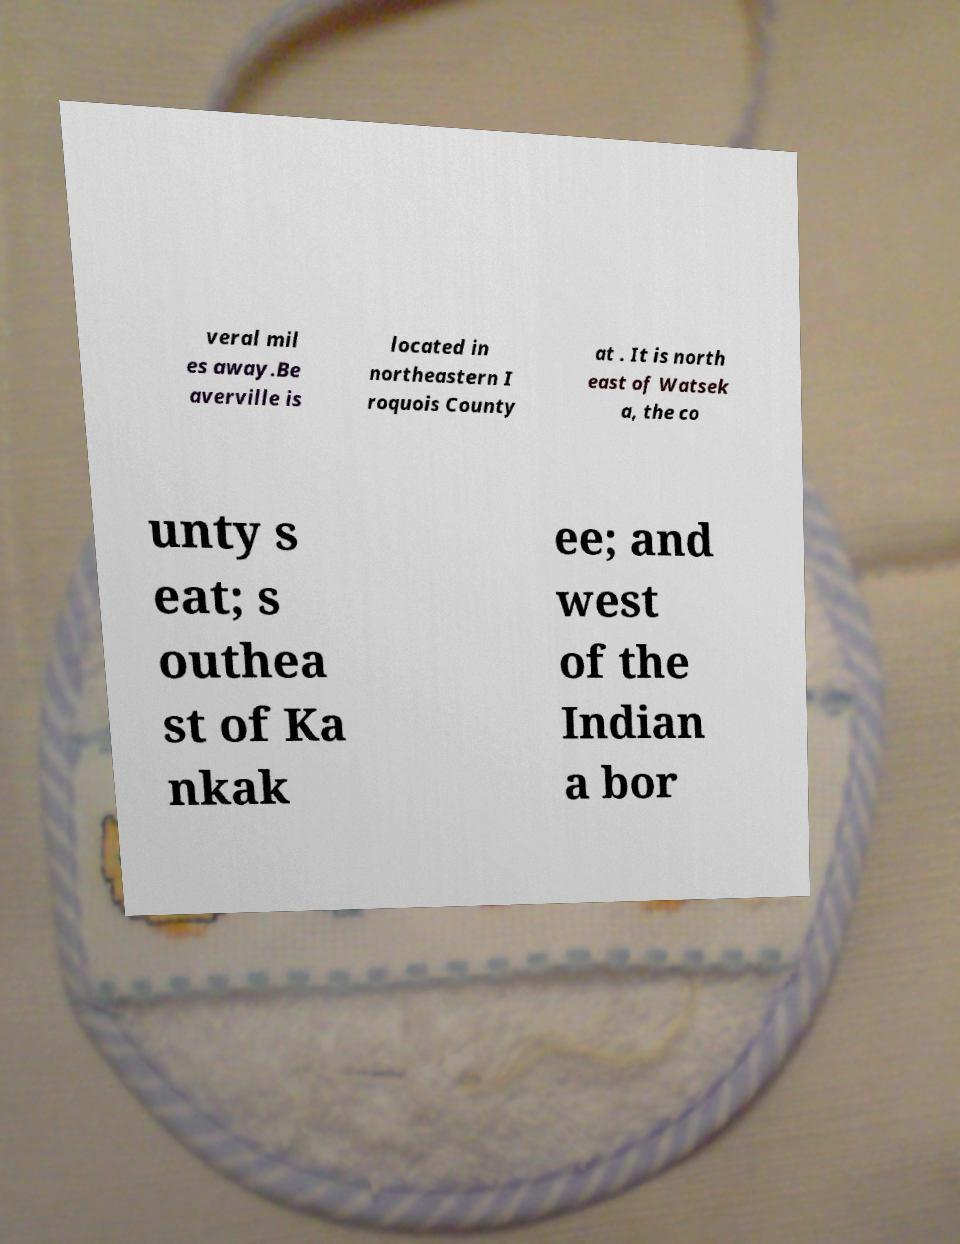Can you accurately transcribe the text from the provided image for me? veral mil es away.Be averville is located in northeastern I roquois County at . It is north east of Watsek a, the co unty s eat; s outhea st of Ka nkak ee; and west of the Indian a bor 